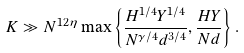<formula> <loc_0><loc_0><loc_500><loc_500>K \gg N ^ { 1 2 \eta } \max \left \{ \frac { H ^ { 1 / 4 } Y ^ { 1 / 4 } } { N ^ { \gamma / 4 } d ^ { 3 / 4 } } , \frac { H Y } { N d } \right \} .</formula> 